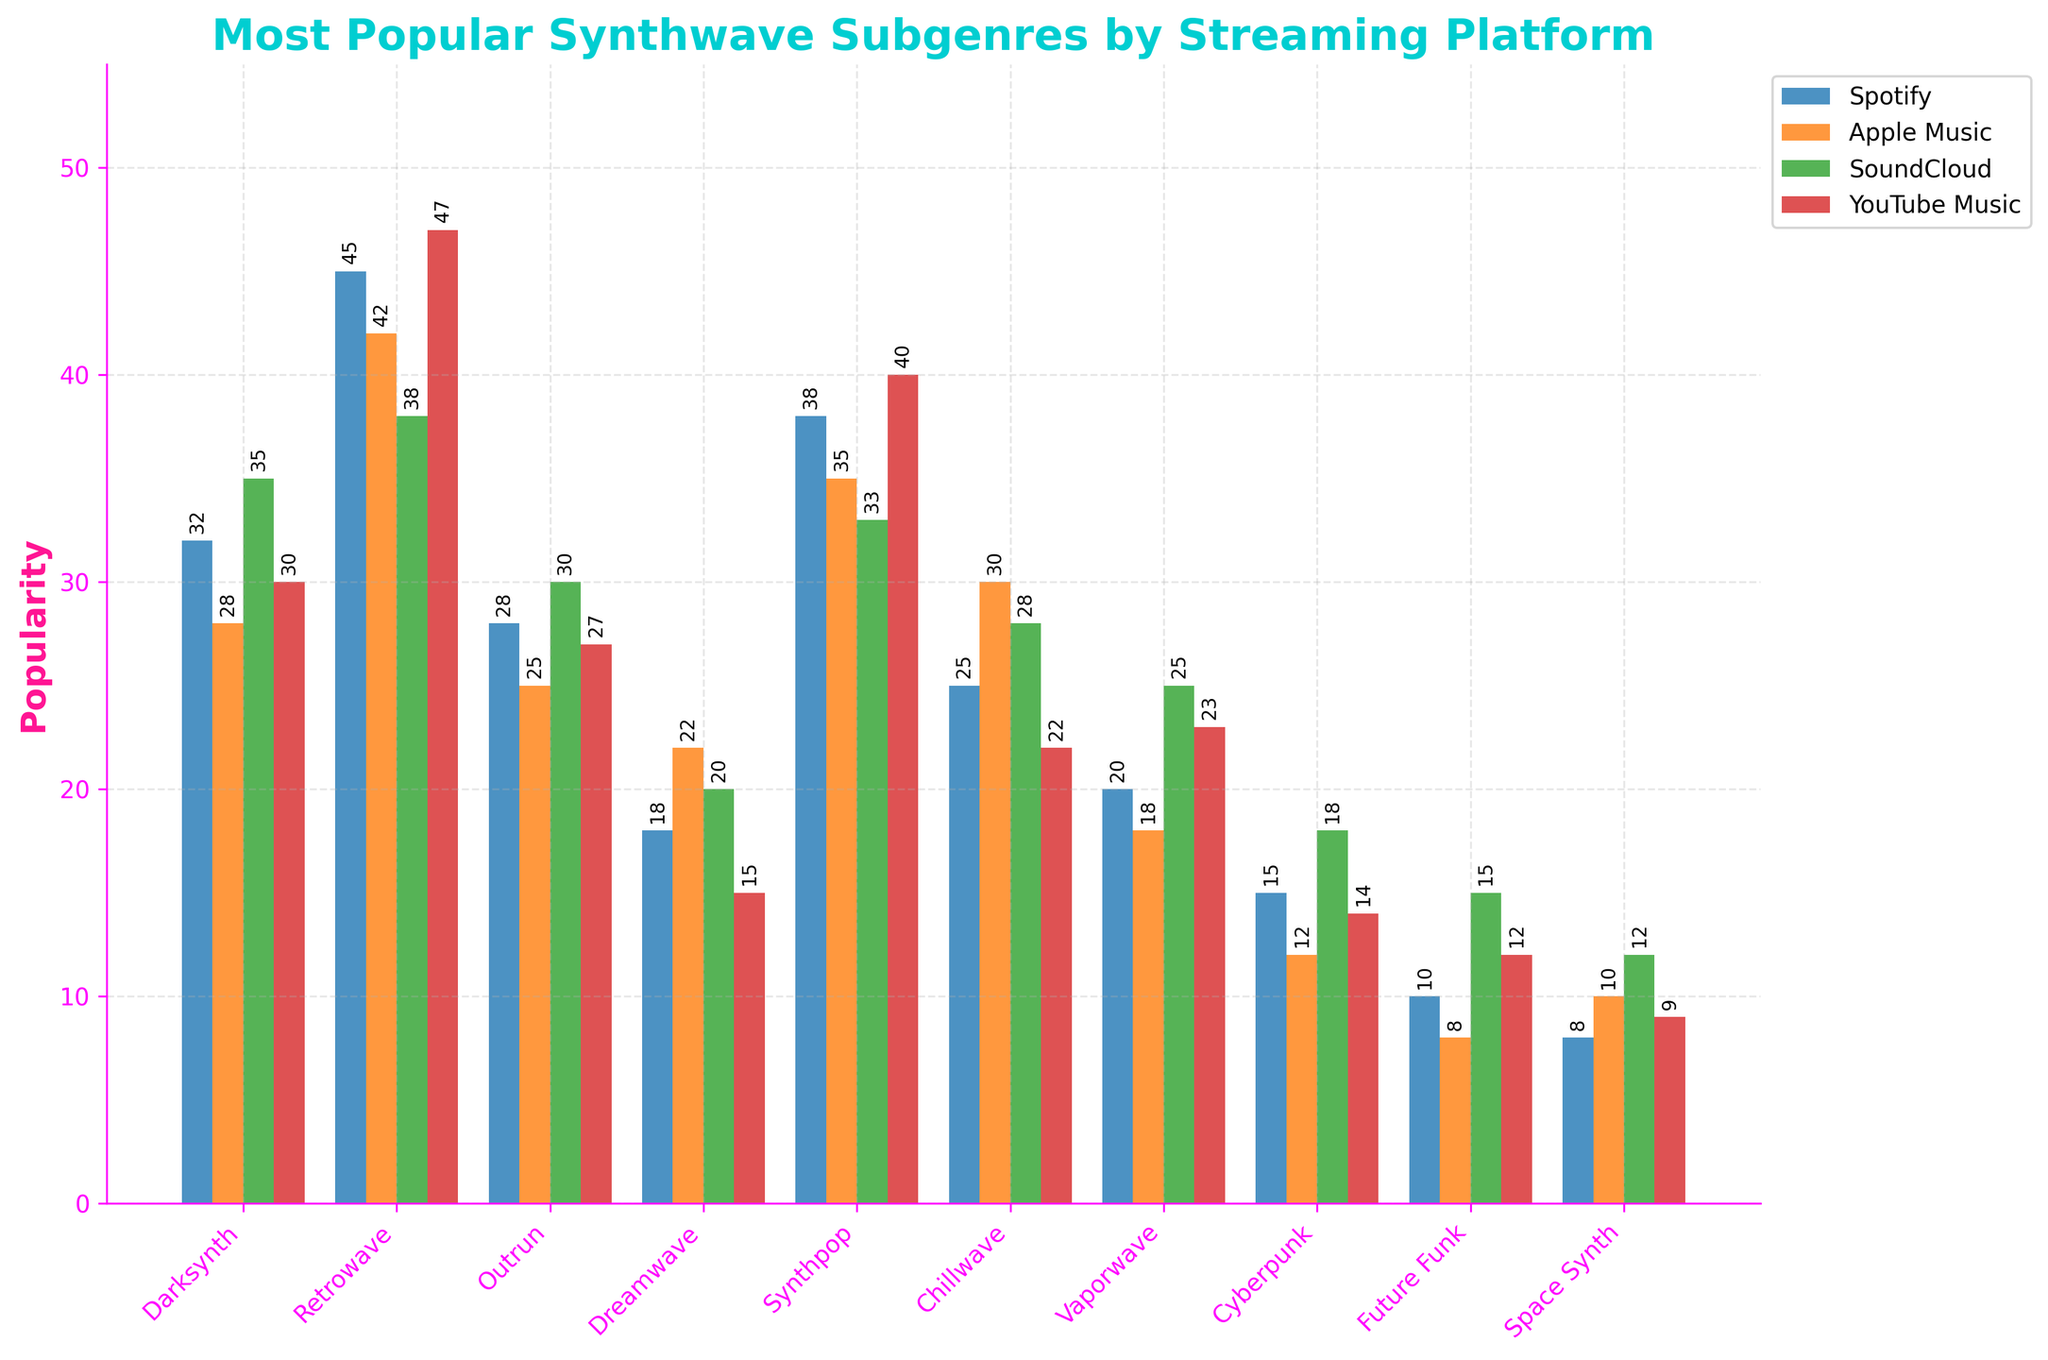What is the most popular synthwave subgenre on Spotify? The tallest bar under the Spotify section represents the most popular synthwave subgenre. It corresponds to Retrowave.
Answer: Retrowave Which platform has the highest popularity for Darksynth? By comparing the heights of the bars for Darksynth across all platforms, the highest bar is for SoundCloud.
Answer: SoundCloud What is the least popular subgenre on YouTube Music? The shortest bar under the YouTube Music section indicates the least popular subgenre, which is Dreamwave.
Answer: Dreamwave How much more popular is Synthpop compared to Cyberpunk on Apple Music? The height of the bar for Synthpop is 35, and for Cyberpunk, it is 12. The difference is 35 - 12 = 23.
Answer: 23 Calculate the average popularity of Chillwave across all platforms. Add the values for Chillwave on all platforms (25 + 30 + 28 + 22) and divide by the number of platforms (4). The sum is 105, so the average is 105 ÷ 4 = 26.25.
Answer: 26.25 Compare the popularity of Vaporwave and Future Funk on SoundCloud. Which one is more popular? By comparing the heights of the bars for Vaporwave (25) and Future Funk (15) on SoundCloud, Vaporwave is more popular.
Answer: Vaporwave What is the total popularity of Retrowave across all platforms? Sum the values of Retrowave on each platform (45 + 42 + 38 + 47), which equals 172.
Answer: 172 Is the popularity of Outrun on Spotify greater than Vaporwave on Apple Music? The height of the bar for Outrun on Spotify is 28, and for Vaporwave on Apple Music, it is 18. Since 28 is greater than 18, the popularity of Outrun on Spotify is greater.
Answer: Yes Which subgenre saw a consistent decrease in popularity from Spotify to YouTube Music? By examining the bars from Spotify decreasing through the platforms to YouTube Music, the subgenre that consistently decreases is Darksynth (32, 28, 35, 30).
Answer: None (Darksynth fluctuates) Identify the subgenre with the highest popularity difference between two platforms. By calculating the differences between platforms for all subgenres, Retrowave has a maximum difference (47 on YouTube Music - 38 on SoundCloud = 9).
Answer: Retrowave 